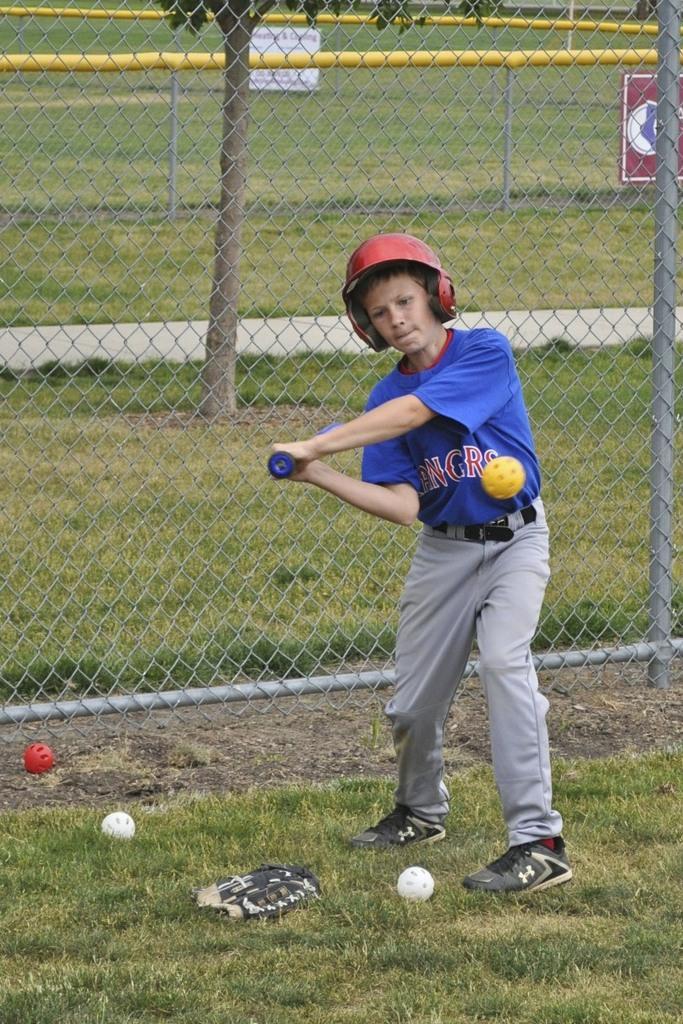How would you summarize this image in a sentence or two? In this picture I can see a boy holding a baseball bat and trying to hit a ball and I can see three balls on the ground and I can see a glove and I can see metal fence and a tree and couple of boards with some text and pictures in the back and I can see grass on the ground and boy wore a cap on his head. 